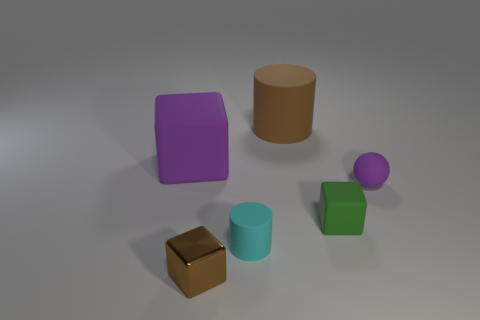Subtract all rubber cubes. How many cubes are left? 1 Add 2 purple spheres. How many objects exist? 8 Subtract all cylinders. How many objects are left? 4 Subtract all brown matte balls. Subtract all tiny rubber things. How many objects are left? 3 Add 1 cyan matte cylinders. How many cyan matte cylinders are left? 2 Add 4 red blocks. How many red blocks exist? 4 Subtract 0 yellow balls. How many objects are left? 6 